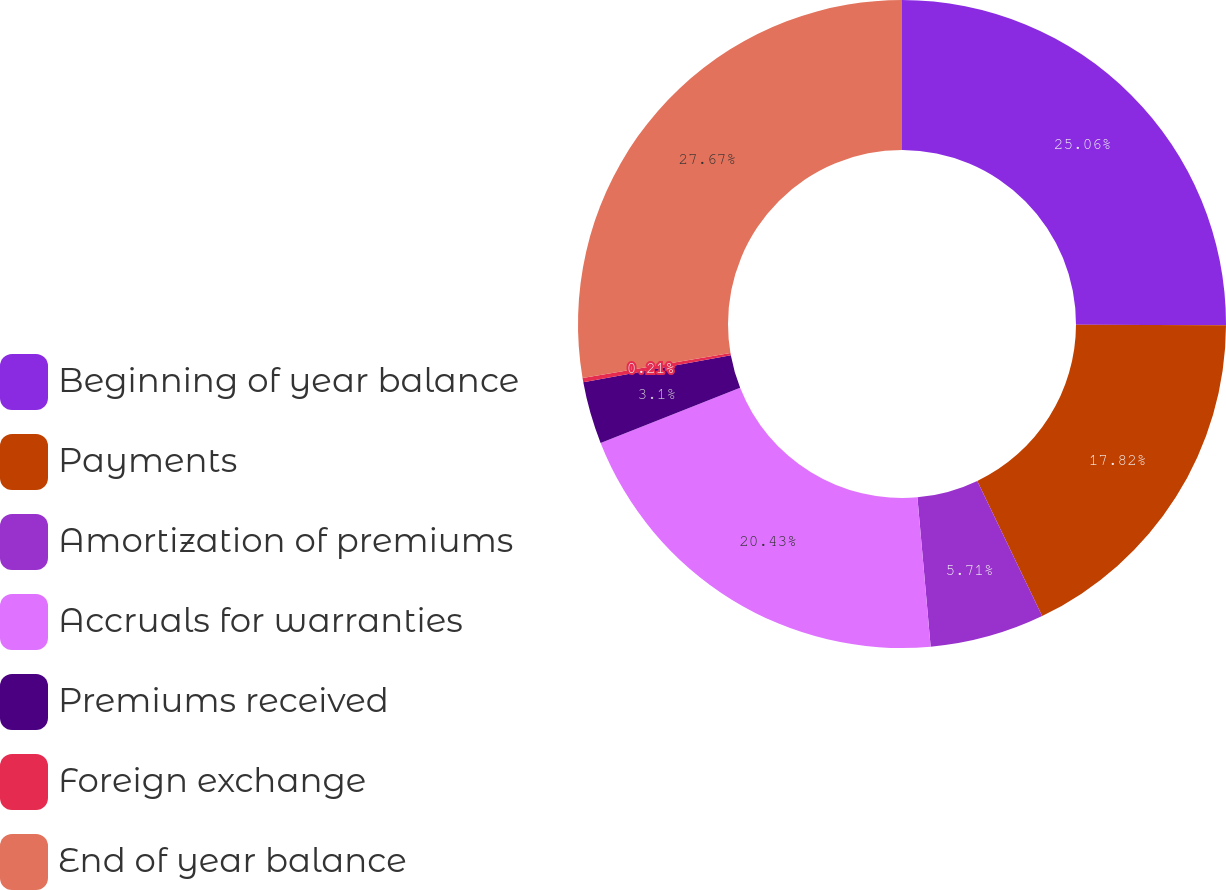Convert chart to OTSL. <chart><loc_0><loc_0><loc_500><loc_500><pie_chart><fcel>Beginning of year balance<fcel>Payments<fcel>Amortization of premiums<fcel>Accruals for warranties<fcel>Premiums received<fcel>Foreign exchange<fcel>End of year balance<nl><fcel>25.06%<fcel>17.82%<fcel>5.71%<fcel>20.43%<fcel>3.1%<fcel>0.21%<fcel>27.67%<nl></chart> 